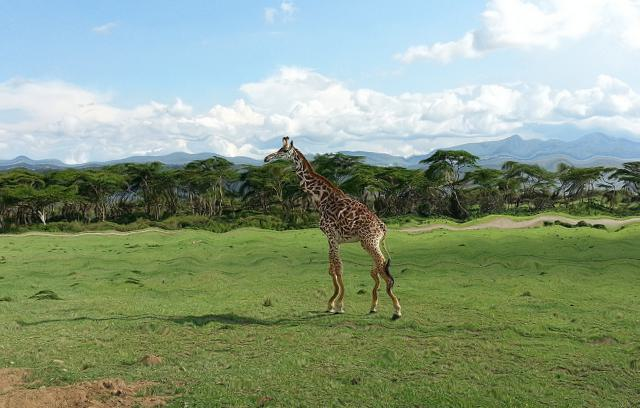Is the presentation of fine details good?
A. Yes
B. No
Answer with the option's letter from the given choices directly. The image presents fine details effectively. The giraffe's distinctive coat patterns, the textural nuances of the grassland, and the trees in the distance are depicted with clarity. Therefore, the answer is A, Yes. 